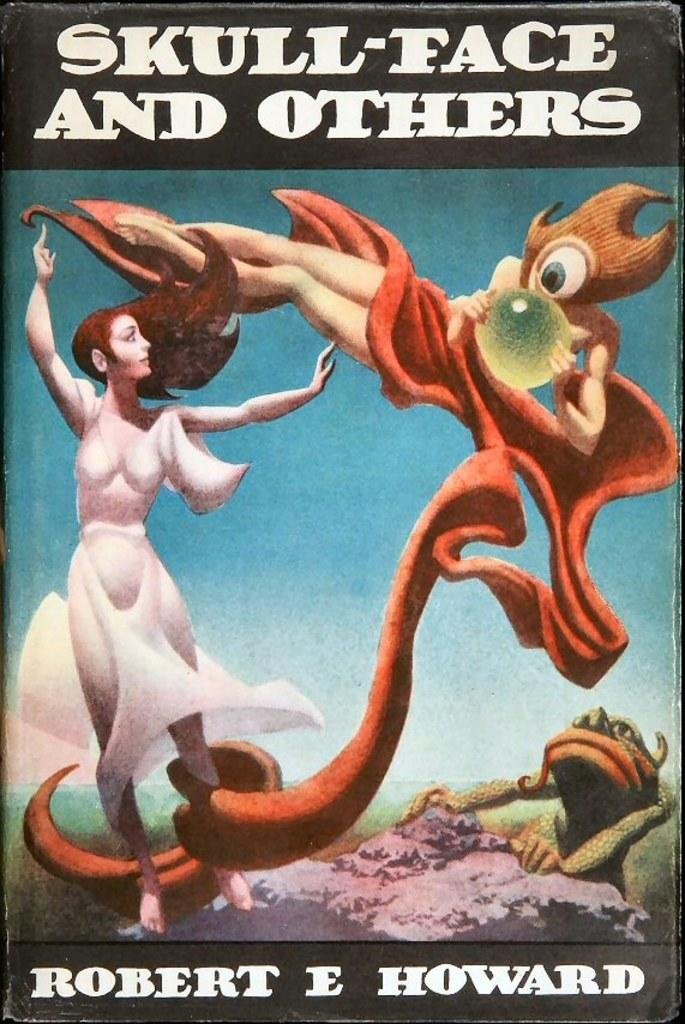Provide a one-sentence caption for the provided image. A book called Skull-face and Others has two monsters on the cover. 